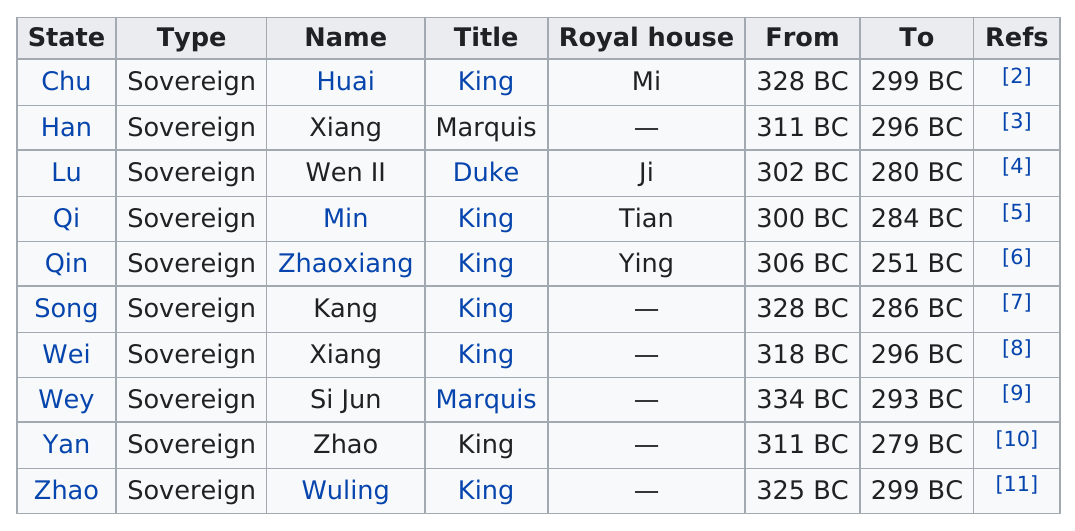Specify some key components in this picture. Zhaoxiang ruled longer than Zhao. There are 10 states represented on the chart. The Marquis Ruler known as Xiang is the other one besides Si Jun. Zhaoxiang was the king who ruled the longest. Which ruler is not a king or a marquis? It is Wen II. 